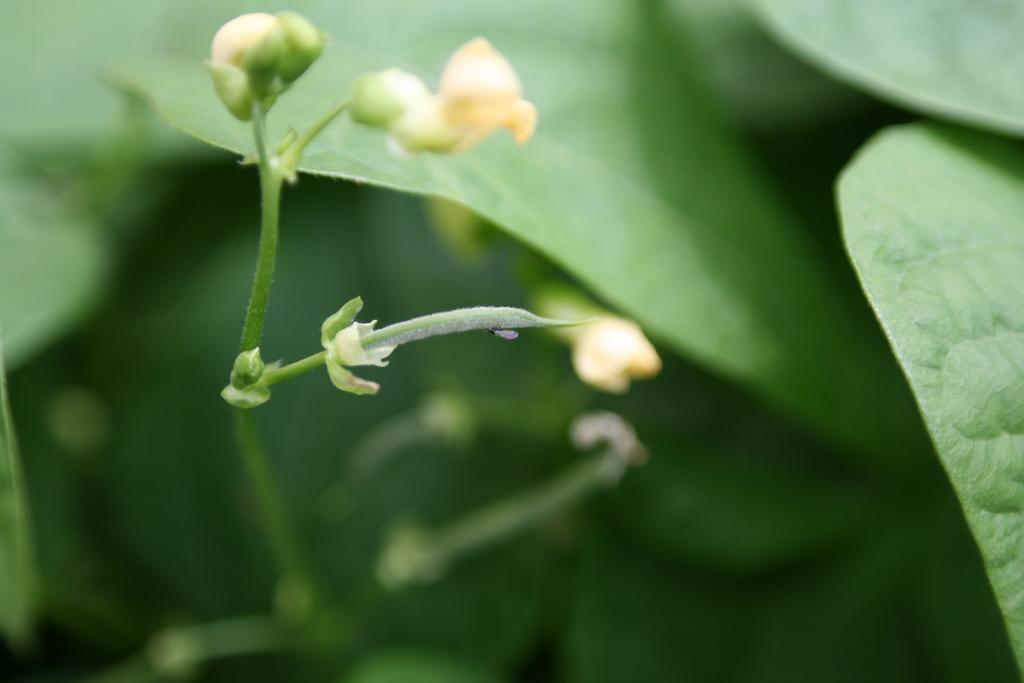What types of plants are visible in the image? The image contains flowers and leaves of a plant. Can you describe the condition of the image? The bottom part of the image is blurred. What type of error can be seen in the image? There is no error present in the image; it is a photograph of flowers and leaves. Can you tell me how many frogs are visible in the image? There are no frogs present in the image; it features flowers and leaves. 